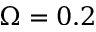Convert formula to latex. <formula><loc_0><loc_0><loc_500><loc_500>\Omega = 0 . 2</formula> 